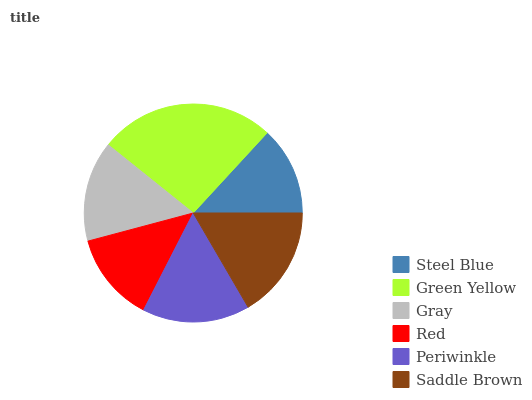Is Steel Blue the minimum?
Answer yes or no. Yes. Is Green Yellow the maximum?
Answer yes or no. Yes. Is Gray the minimum?
Answer yes or no. No. Is Gray the maximum?
Answer yes or no. No. Is Green Yellow greater than Gray?
Answer yes or no. Yes. Is Gray less than Green Yellow?
Answer yes or no. Yes. Is Gray greater than Green Yellow?
Answer yes or no. No. Is Green Yellow less than Gray?
Answer yes or no. No. Is Periwinkle the high median?
Answer yes or no. Yes. Is Gray the low median?
Answer yes or no. Yes. Is Gray the high median?
Answer yes or no. No. Is Saddle Brown the low median?
Answer yes or no. No. 